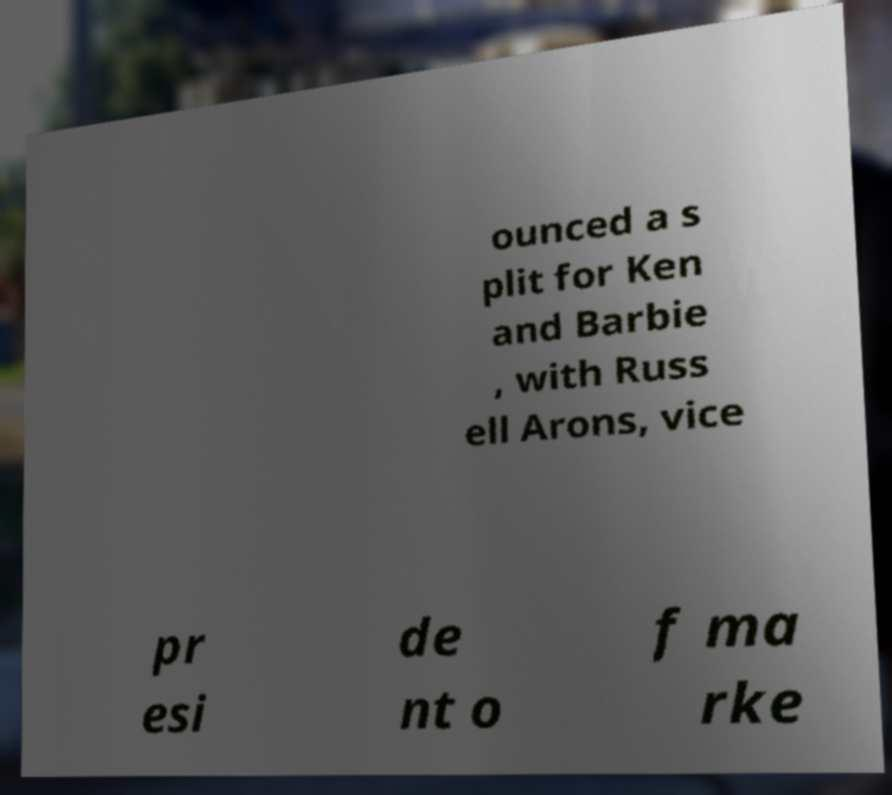I need the written content from this picture converted into text. Can you do that? ounced a s plit for Ken and Barbie , with Russ ell Arons, vice pr esi de nt o f ma rke 